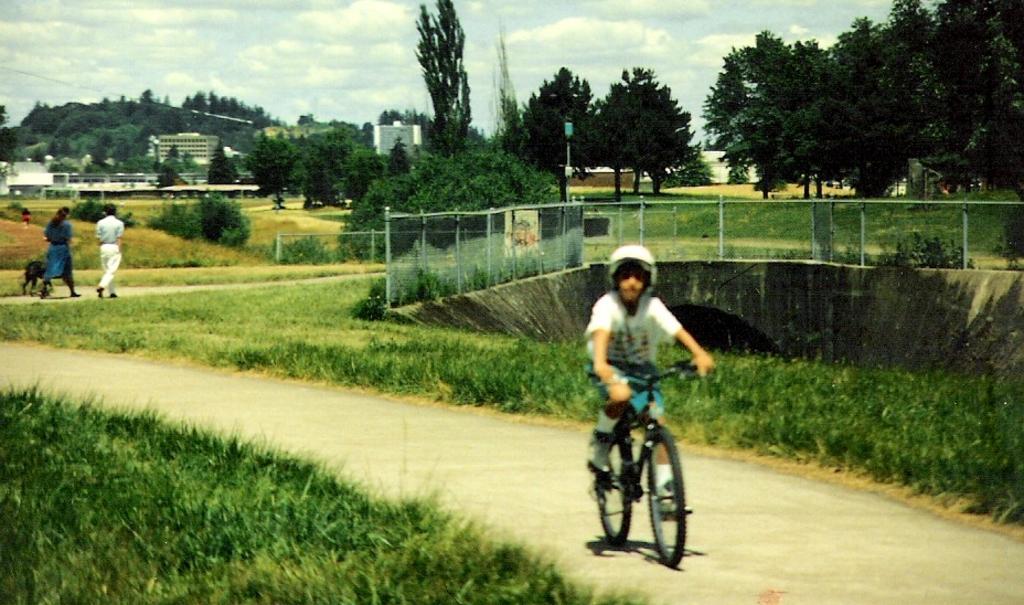Please provide a concise description of this image. A boy is riding a bicycle wearing helmet. A couple are walking along with a dog in the background. 